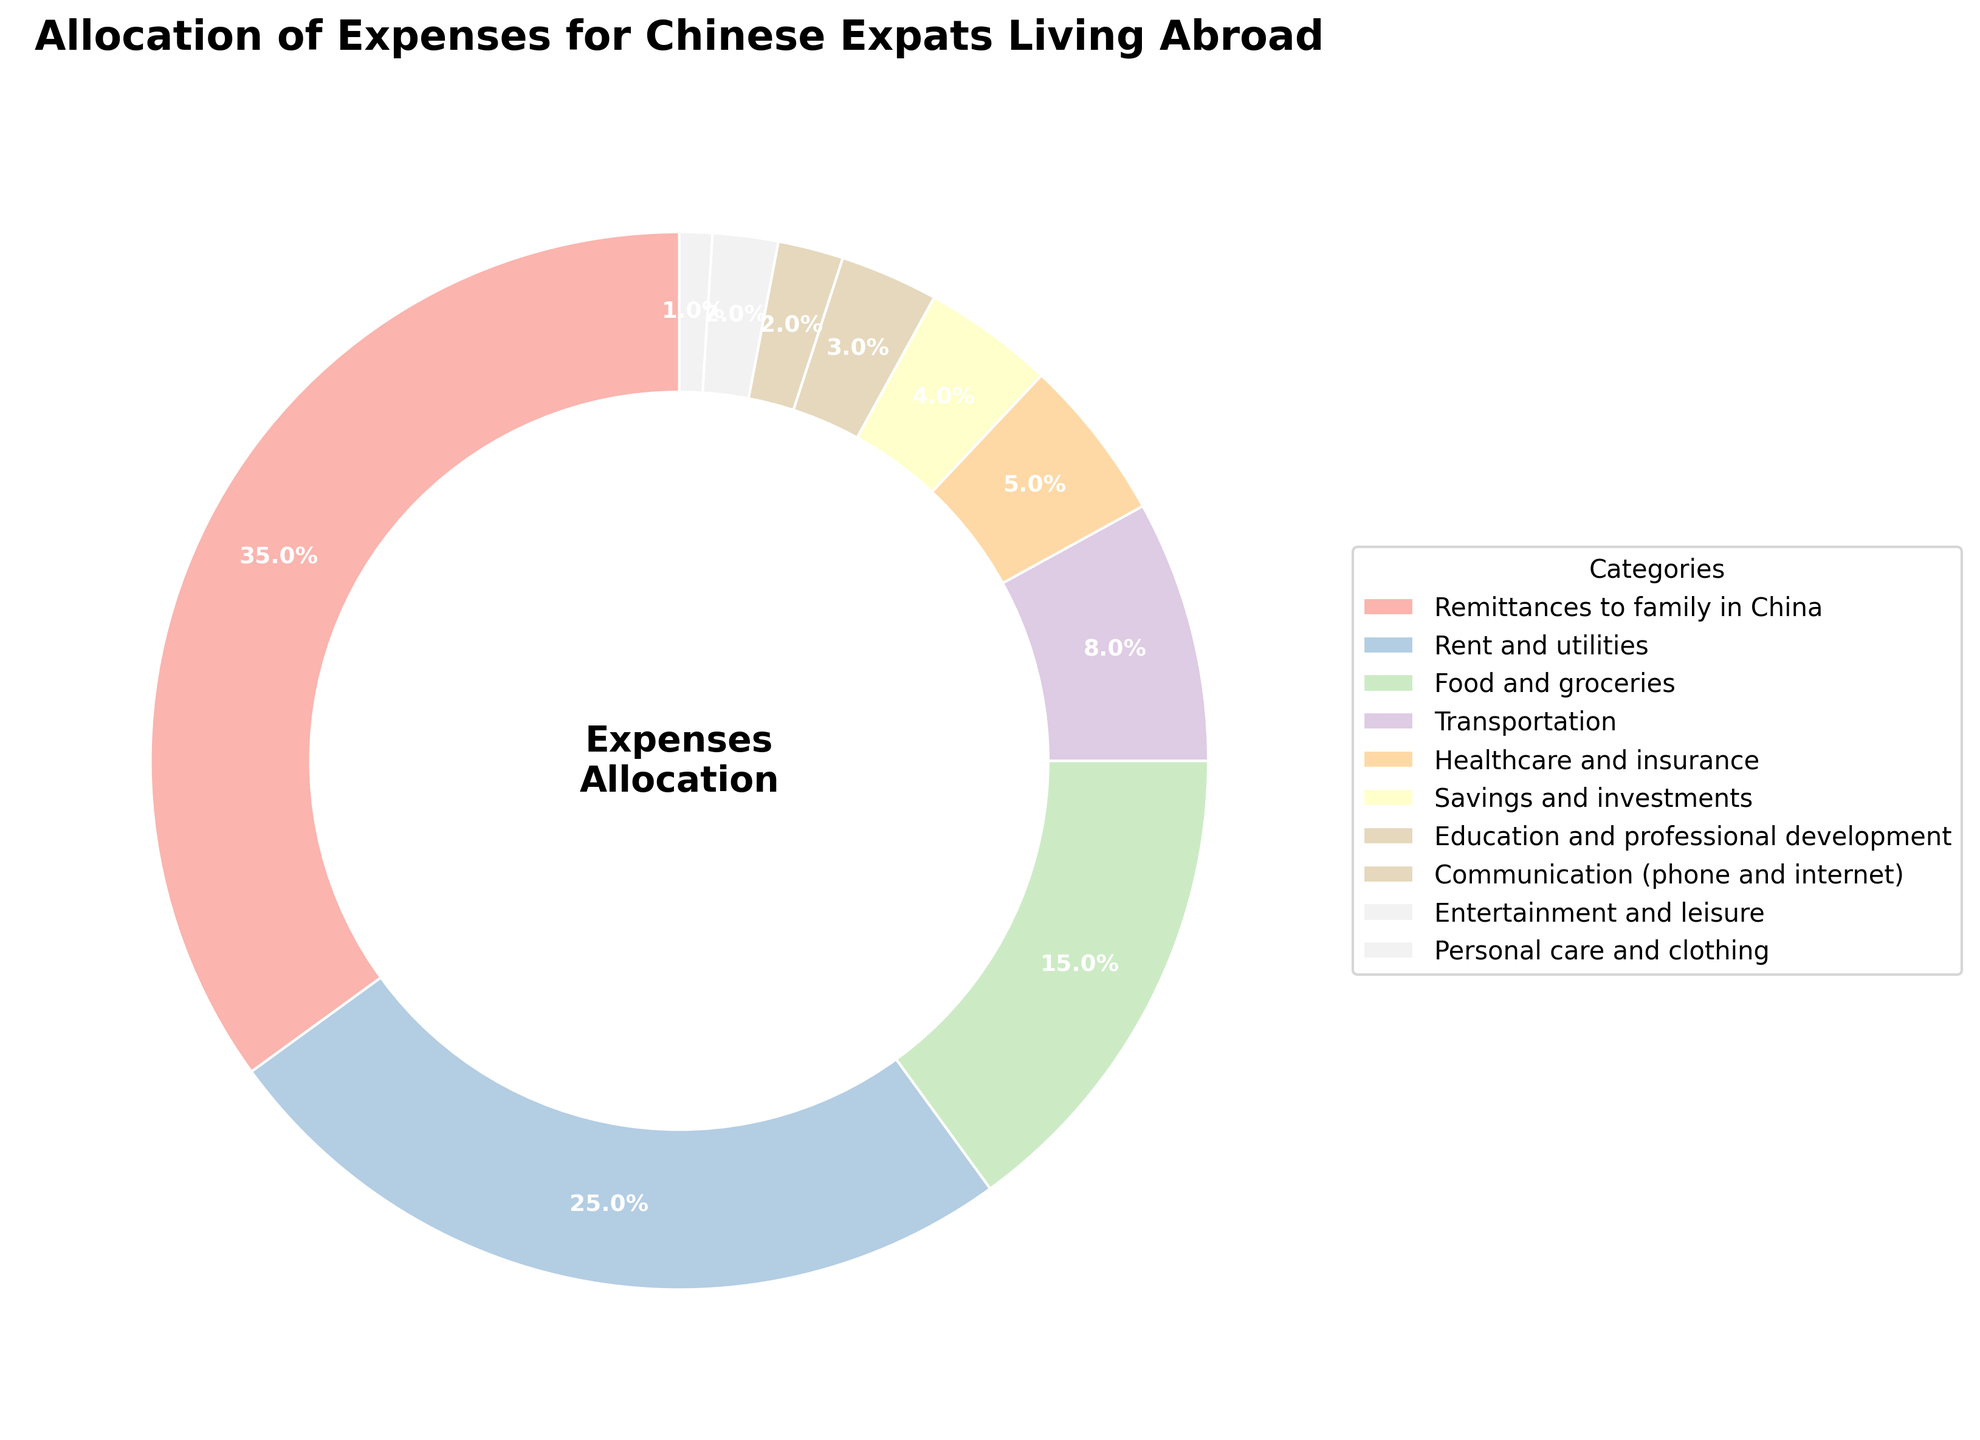what percentage of expenses is allocated towards rent and utilities? Refer to the pie chart segment labeled "Rent and utilities" which indicates the percentage directly.
Answer: 25% which category has the second largest allocation of expenses? Observe the pie chart and identify the segment with the second largest slice after "Remittances to family in China."
Answer: Rent and utilities how much more is spent on food and groceries compared to personal care and clothing? Determine the percentage allocated to both categories (15% for food and groceries and 1% for personal care and clothing) and calculate their difference: (15% - 1%).
Answer: 14% is the allocation for savings and investments greater than healthcare and insurance? Compare the percentages of savings and investments (4%) and healthcare and insurance (5%) to see which is larger.
Answer: No what is the total percentage allocated for education and professional development, and communication? Add the percentages for both categories: 3% (education and professional development) + 2% (communication).
Answer: 5% which category has a smaller allocation: entertainment and leisure or transportation? Compare the two categories' percentages: 2% (entertainment and leisure) vs. 8% (transportation).
Answer: Entertainment and leisure what percentage is allocated to expenses other than remittances, rent, and food? Subtract the sum of percentages for remittances (35%), rent (25%), and food (15%) from 100%: 100% - (35% + 25% + 15%).
Answer: 25% how does the allocation for healthcare and insurance compare to communication? Compare the two categories' percentages: 5% (healthcare and insurance) vs. 2% (communication).
Answer: Healthcare and insurance is greater what is the combined percentage for the two smallest allocation categories? Add the percentages for the smallest categories, communication (2%) and personal care and clothing (1%): 2% + 1%.
Answer: 3% 